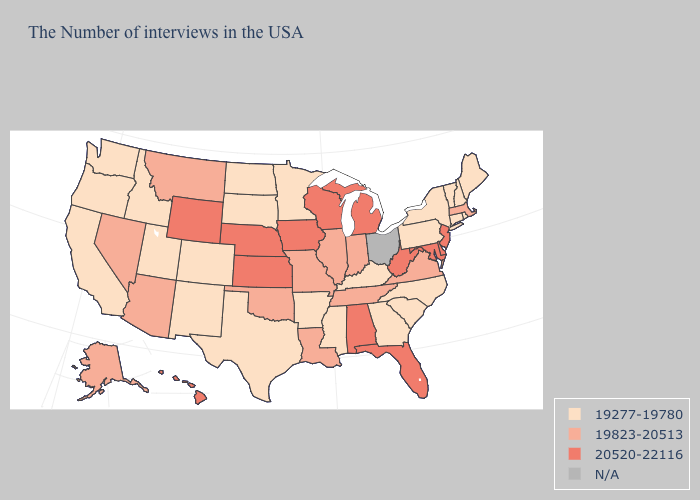Does Alabama have the highest value in the USA?
Short answer required. Yes. What is the value of Maine?
Concise answer only. 19277-19780. What is the lowest value in states that border Georgia?
Keep it brief. 19277-19780. Name the states that have a value in the range 19823-20513?
Be succinct. Massachusetts, Virginia, Indiana, Tennessee, Illinois, Louisiana, Missouri, Oklahoma, Montana, Arizona, Nevada, Alaska. Name the states that have a value in the range 19277-19780?
Quick response, please. Maine, Rhode Island, New Hampshire, Vermont, Connecticut, New York, Pennsylvania, North Carolina, South Carolina, Georgia, Kentucky, Mississippi, Arkansas, Minnesota, Texas, South Dakota, North Dakota, Colorado, New Mexico, Utah, Idaho, California, Washington, Oregon. Among the states that border Connecticut , does Massachusetts have the lowest value?
Keep it brief. No. Among the states that border Louisiana , which have the highest value?
Concise answer only. Mississippi, Arkansas, Texas. Does Arizona have the highest value in the USA?
Be succinct. No. Name the states that have a value in the range 19277-19780?
Quick response, please. Maine, Rhode Island, New Hampshire, Vermont, Connecticut, New York, Pennsylvania, North Carolina, South Carolina, Georgia, Kentucky, Mississippi, Arkansas, Minnesota, Texas, South Dakota, North Dakota, Colorado, New Mexico, Utah, Idaho, California, Washington, Oregon. What is the highest value in states that border Alabama?
Write a very short answer. 20520-22116. What is the highest value in states that border Maryland?
Concise answer only. 20520-22116. Does the map have missing data?
Concise answer only. Yes. What is the value of Nebraska?
Answer briefly. 20520-22116. What is the lowest value in the South?
Give a very brief answer. 19277-19780. Which states have the lowest value in the USA?
Write a very short answer. Maine, Rhode Island, New Hampshire, Vermont, Connecticut, New York, Pennsylvania, North Carolina, South Carolina, Georgia, Kentucky, Mississippi, Arkansas, Minnesota, Texas, South Dakota, North Dakota, Colorado, New Mexico, Utah, Idaho, California, Washington, Oregon. 